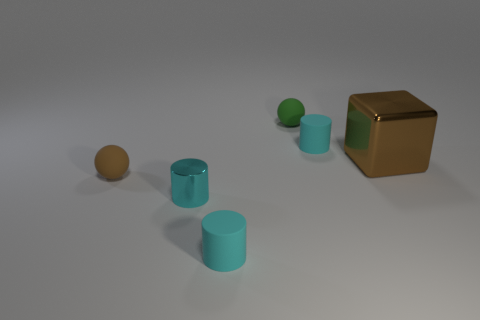The surfaces of these objects appear to have different textures. Could you describe those textures? Certainly. The rubber cylinders and the green ball have a matte surface, which diffuses the light and gives them a soft appearance. The brown cube, on the other hand, has a reflective, almost metallic finish, producing highlights and sharp reflections that contribute to its solid and polished look. The tan ball shares a similar sheen to the cube but with a more muted reflection, suggesting a smoother but still somewhat reflective texture. 